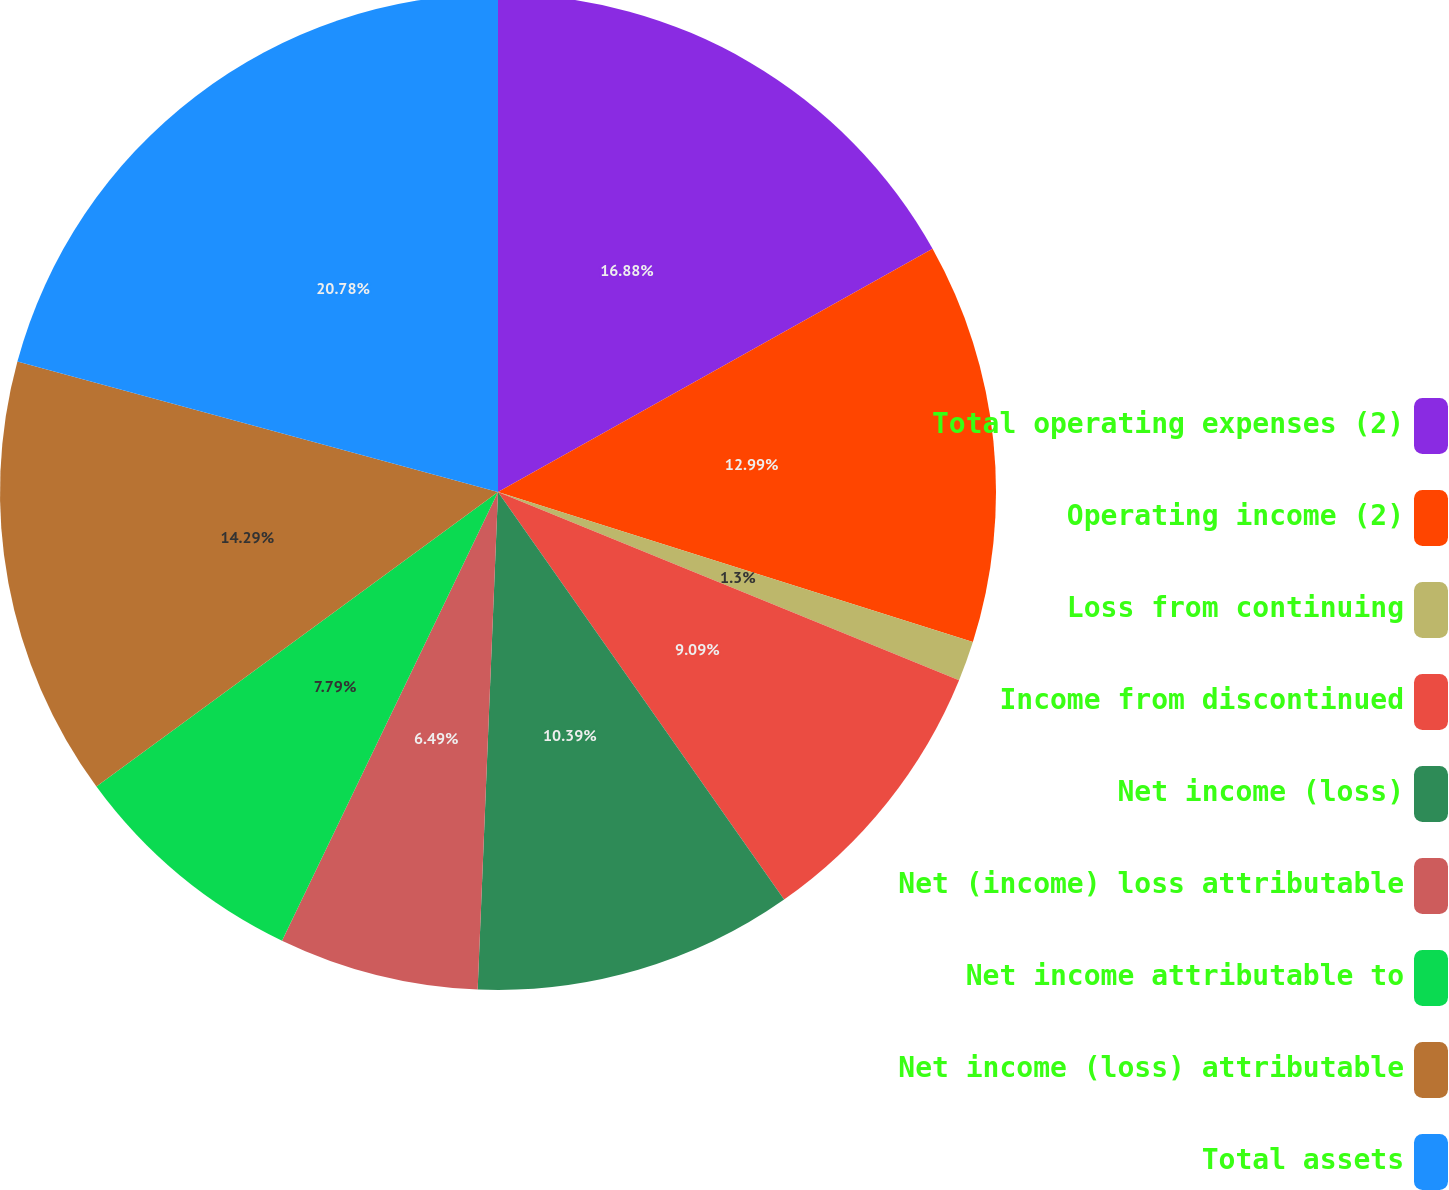Convert chart to OTSL. <chart><loc_0><loc_0><loc_500><loc_500><pie_chart><fcel>Total operating expenses (2)<fcel>Operating income (2)<fcel>Loss from continuing<fcel>Income from discontinued<fcel>Net income (loss)<fcel>Net (income) loss attributable<fcel>Net income attributable to<fcel>Net income (loss) attributable<fcel>Total assets<nl><fcel>16.88%<fcel>12.99%<fcel>1.3%<fcel>9.09%<fcel>10.39%<fcel>6.49%<fcel>7.79%<fcel>14.29%<fcel>20.78%<nl></chart> 